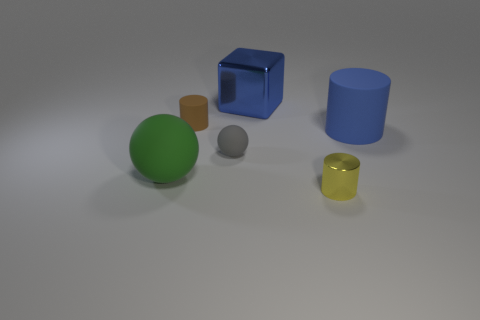There is a object that is the same color as the large block; what is its material?
Your answer should be very brief. Rubber. Is the number of tiny balls that are in front of the blue shiny object the same as the number of brown matte cylinders left of the yellow object?
Your answer should be very brief. Yes. The cylinder that is in front of the sphere that is behind the big thing to the left of the blue cube is what color?
Give a very brief answer. Yellow. There is a large blue thing that is right of the yellow object; what shape is it?
Your response must be concise. Cylinder. The large thing that is the same material as the large ball is what shape?
Keep it short and to the point. Cylinder. Are there any other things that have the same shape as the big shiny object?
Provide a succinct answer. No. What number of big objects are right of the blue rubber cylinder?
Ensure brevity in your answer.  0. Is the number of shiny cylinders that are behind the large green rubber sphere the same as the number of small matte objects?
Ensure brevity in your answer.  No. Is the material of the brown cylinder the same as the yellow thing?
Your answer should be very brief. No. What size is the cylinder that is on the left side of the big blue matte object and behind the tiny yellow cylinder?
Offer a very short reply. Small. 